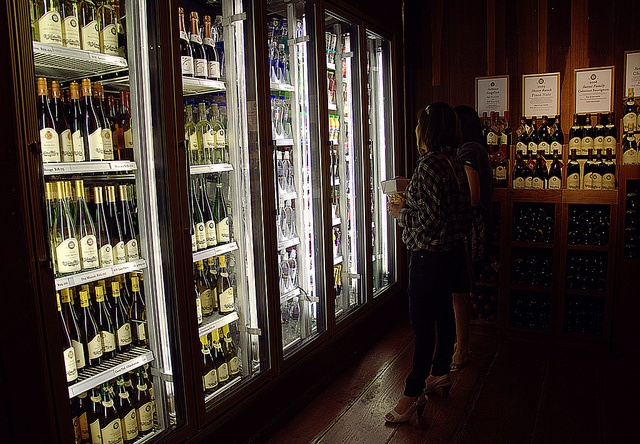Describe the objects in this image and their specific colors. I can see refrigerator in black, beige, and olive tones, refrigerator in black, ivory, darkgray, and gray tones, refrigerator in black, white, gray, and darkgray tones, people in black, maroon, and gray tones, and refrigerator in black, white, gray, and darkgray tones in this image. 